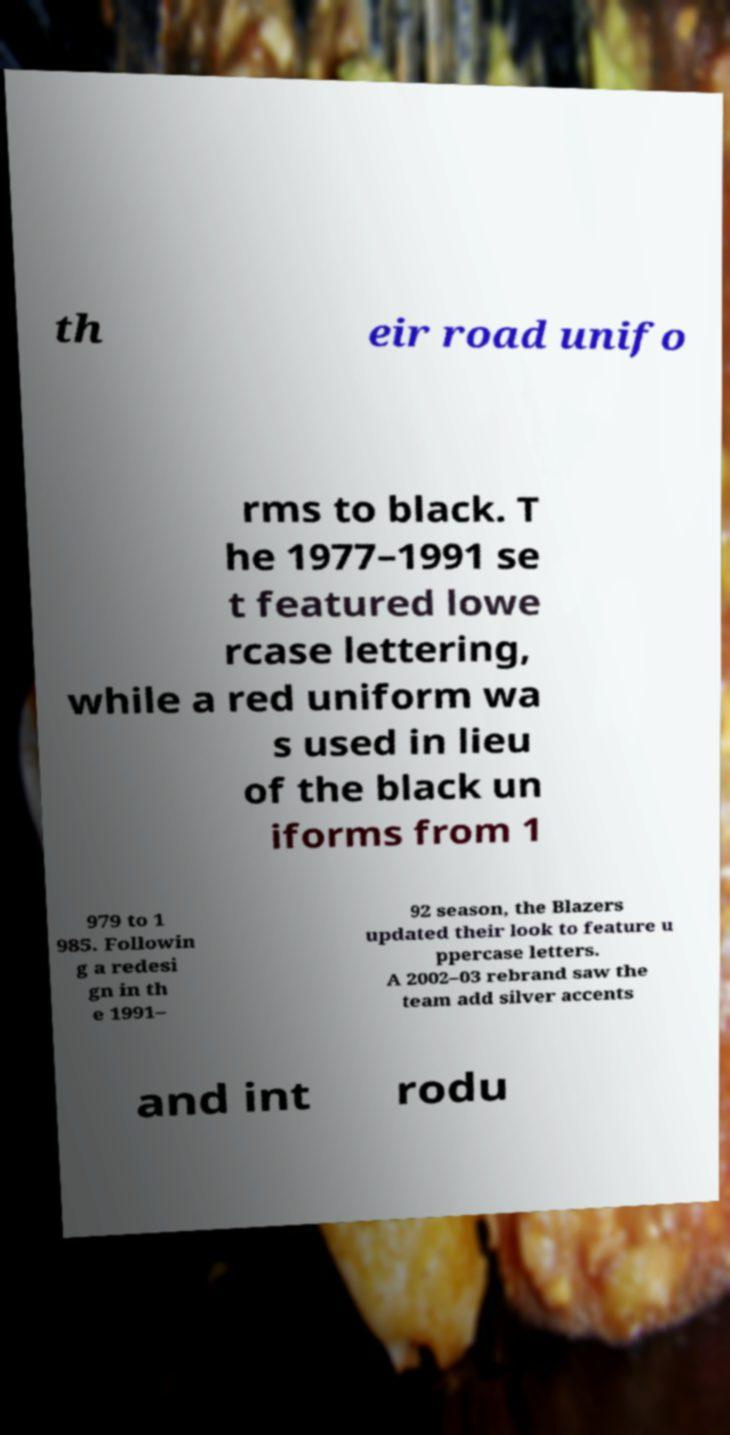Please identify and transcribe the text found in this image. th eir road unifo rms to black. T he 1977–1991 se t featured lowe rcase lettering, while a red uniform wa s used in lieu of the black un iforms from 1 979 to 1 985. Followin g a redesi gn in th e 1991– 92 season, the Blazers updated their look to feature u ppercase letters. A 2002–03 rebrand saw the team add silver accents and int rodu 